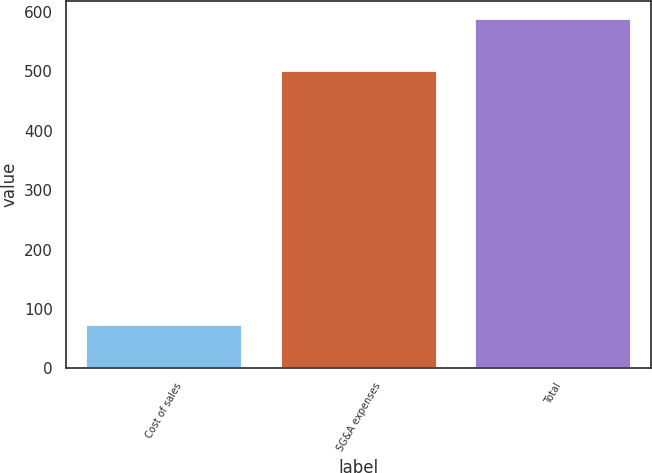<chart> <loc_0><loc_0><loc_500><loc_500><bar_chart><fcel>Cost of sales<fcel>SG&A expenses<fcel>Total<nl><fcel>73<fcel>500<fcel>589<nl></chart> 